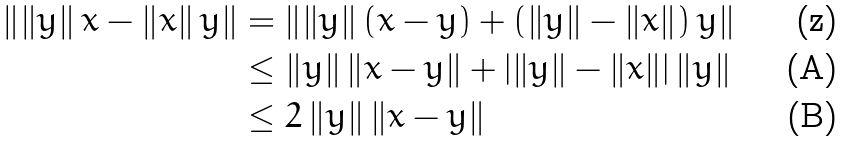Convert formula to latex. <formula><loc_0><loc_0><loc_500><loc_500>\left \| \left \| y \right \| x - \left \| x \right \| y \right \| & = \left \| \left \| y \right \| \left ( x - y \right ) + \left ( \left \| y \right \| - \left \| x \right \| \right ) y \right \| \\ & \leq \left \| y \right \| \left \| x - y \right \| + \left | \left \| y \right \| - \left \| x \right \| \right | \left \| y \right \| \\ & \leq 2 \left \| y \right \| \left \| x - y \right \|</formula> 